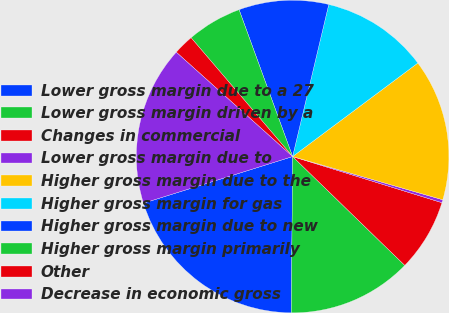Convert chart. <chart><loc_0><loc_0><loc_500><loc_500><pie_chart><fcel>Lower gross margin due to a 27<fcel>Lower gross margin driven by a<fcel>Changes in commercial<fcel>Lower gross margin due to<fcel>Higher gross margin due to the<fcel>Higher gross margin for gas<fcel>Higher gross margin due to new<fcel>Higher gross margin primarily<fcel>Other<fcel>Decrease in economic gross<nl><fcel>20.05%<fcel>12.87%<fcel>7.49%<fcel>0.31%<fcel>14.67%<fcel>11.08%<fcel>9.28%<fcel>5.69%<fcel>2.11%<fcel>16.46%<nl></chart> 